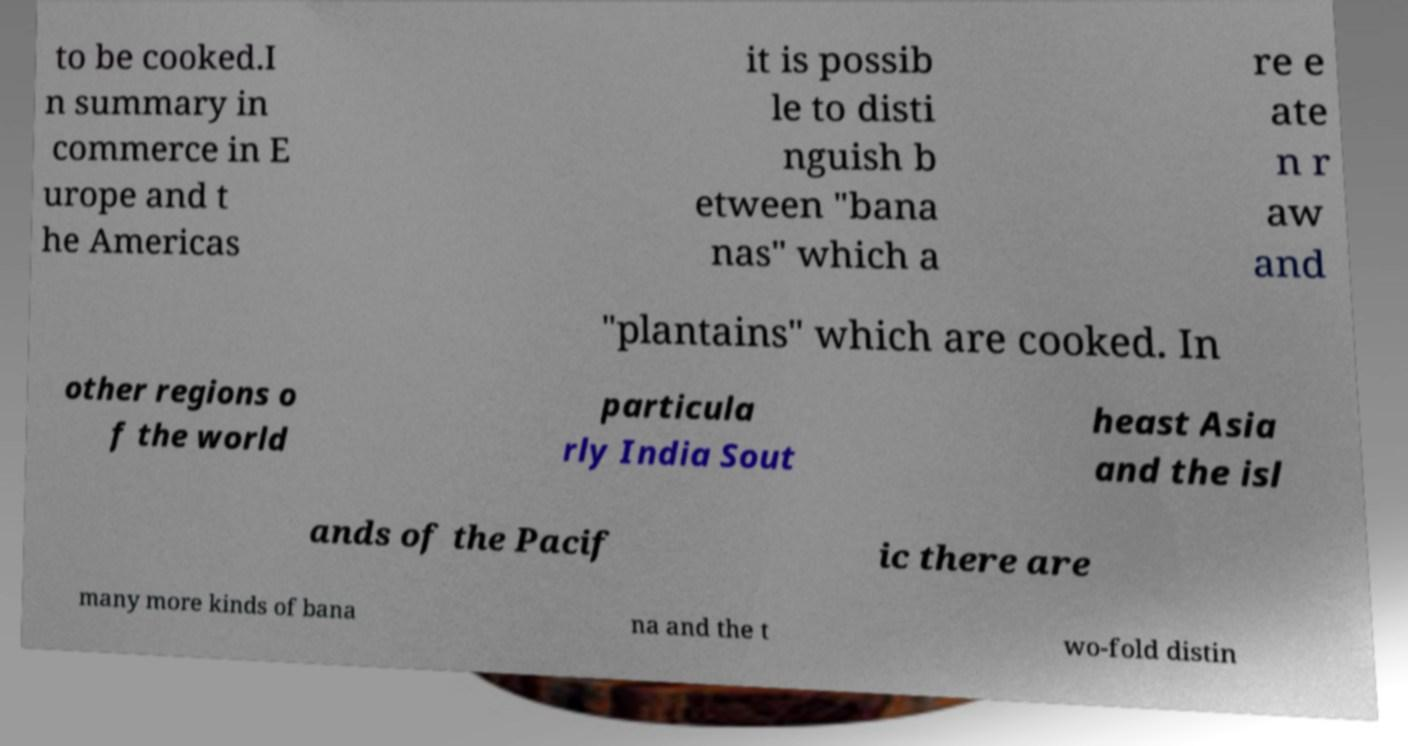For documentation purposes, I need the text within this image transcribed. Could you provide that? to be cooked.I n summary in commerce in E urope and t he Americas it is possib le to disti nguish b etween "bana nas" which a re e ate n r aw and "plantains" which are cooked. In other regions o f the world particula rly India Sout heast Asia and the isl ands of the Pacif ic there are many more kinds of bana na and the t wo-fold distin 